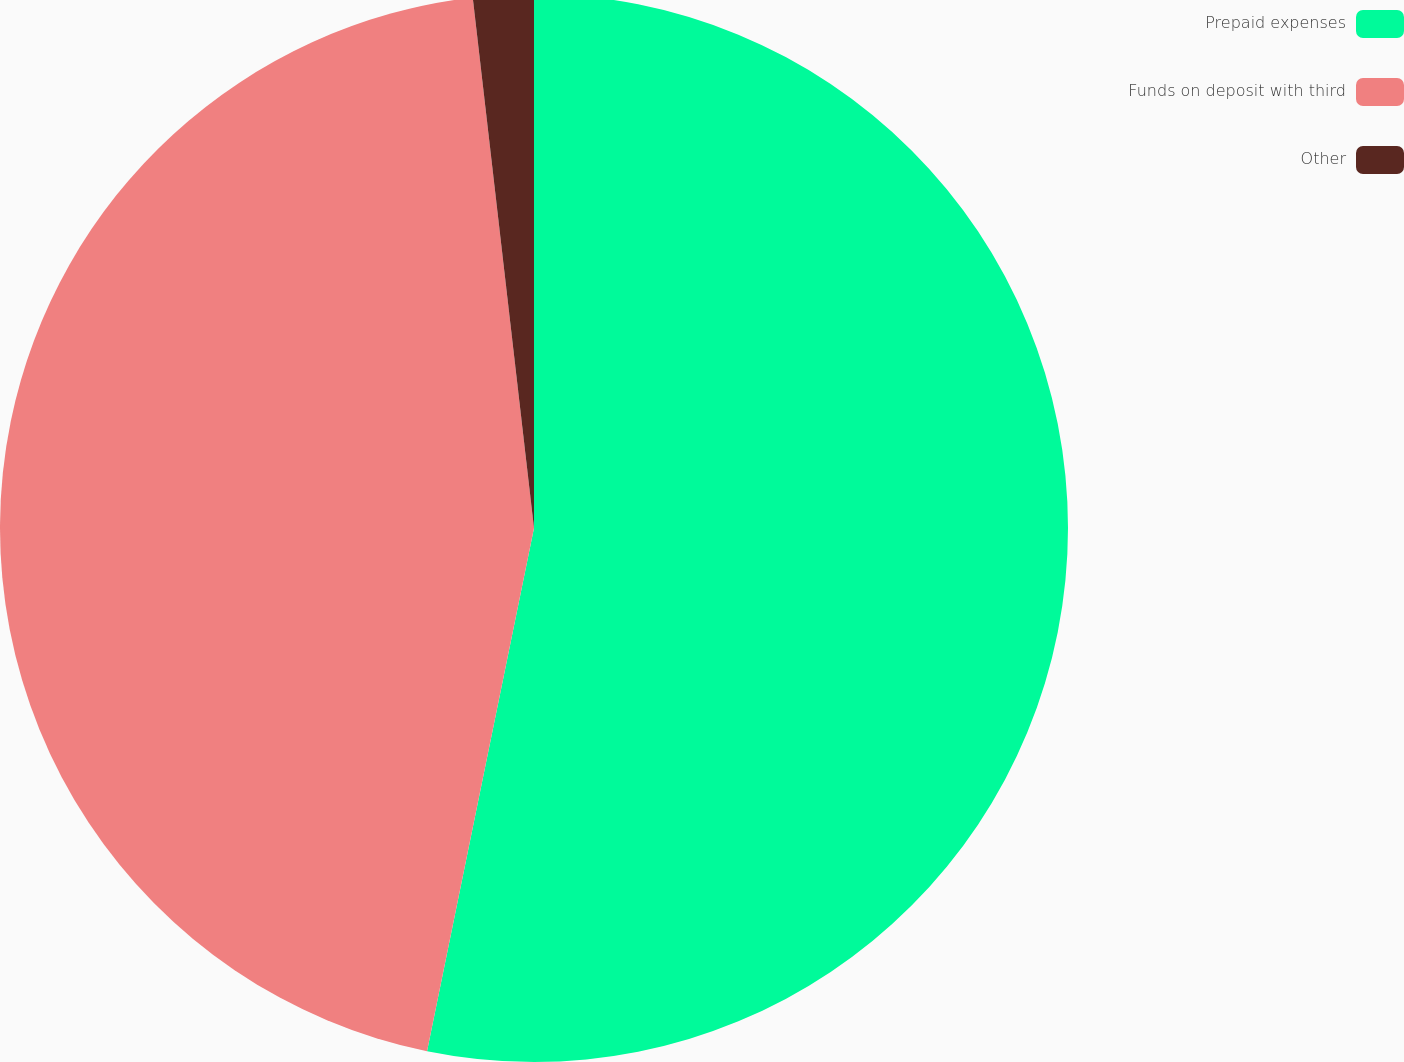Convert chart. <chart><loc_0><loc_0><loc_500><loc_500><pie_chart><fcel>Prepaid expenses<fcel>Funds on deposit with third<fcel>Other<nl><fcel>53.21%<fcel>44.96%<fcel>1.83%<nl></chart> 